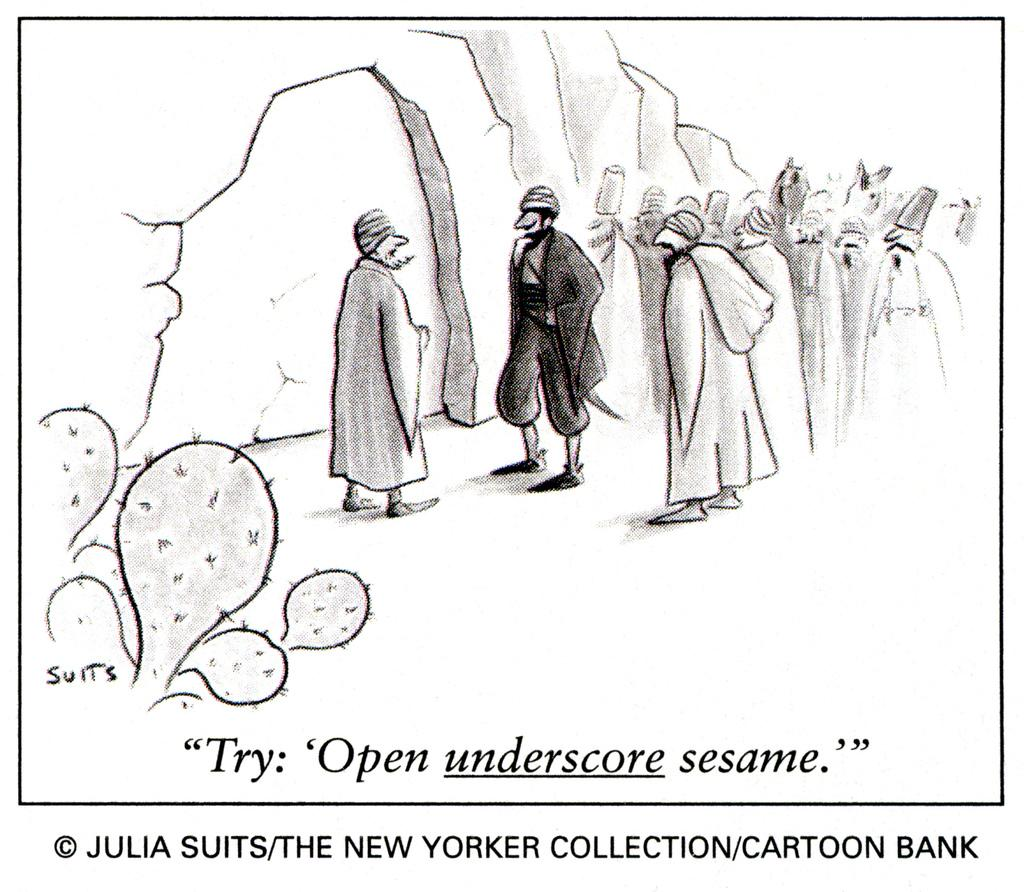Who or what is present in the image? There are people and plants in the image. What else can be seen in the image besides people and plants? There is some text and a watermark in the image. Can you see a friend sailing a ship in the image? There is no friend or ship present in the image. 